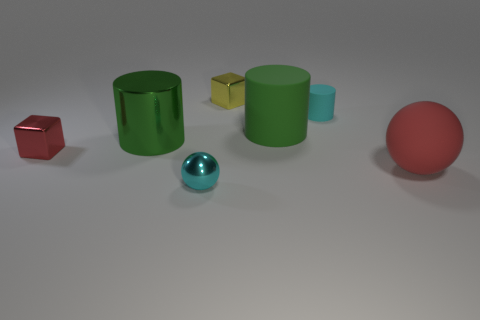Subtract all large cylinders. How many cylinders are left? 1 Subtract all cyan cylinders. How many cylinders are left? 2 Subtract all balls. How many objects are left? 5 Add 6 big yellow shiny cylinders. How many big yellow shiny cylinders exist? 6 Add 2 metal cylinders. How many objects exist? 9 Subtract 0 brown cylinders. How many objects are left? 7 Subtract 1 balls. How many balls are left? 1 Subtract all brown cubes. Subtract all cyan balls. How many cubes are left? 2 Subtract all yellow cubes. How many purple spheres are left? 0 Subtract all metallic blocks. Subtract all cyan matte things. How many objects are left? 4 